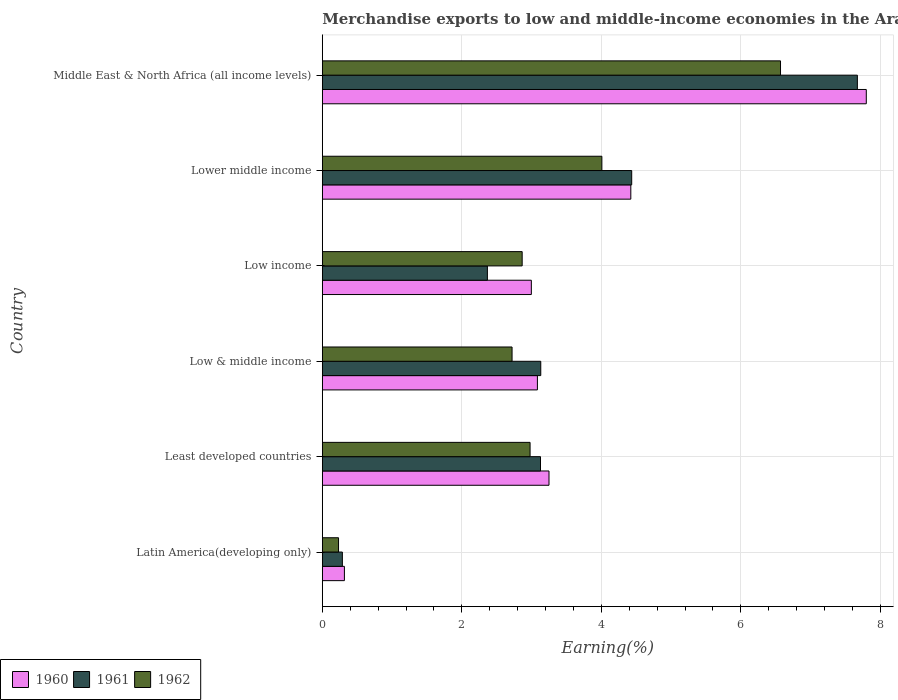How many different coloured bars are there?
Offer a very short reply. 3. How many groups of bars are there?
Offer a terse response. 6. Are the number of bars on each tick of the Y-axis equal?
Provide a short and direct response. Yes. How many bars are there on the 6th tick from the top?
Provide a short and direct response. 3. How many bars are there on the 2nd tick from the bottom?
Your answer should be compact. 3. What is the label of the 2nd group of bars from the top?
Make the answer very short. Lower middle income. In how many cases, is the number of bars for a given country not equal to the number of legend labels?
Keep it short and to the point. 0. What is the percentage of amount earned from merchandise exports in 1962 in Low & middle income?
Ensure brevity in your answer.  2.72. Across all countries, what is the maximum percentage of amount earned from merchandise exports in 1960?
Your answer should be very brief. 7.8. Across all countries, what is the minimum percentage of amount earned from merchandise exports in 1961?
Keep it short and to the point. 0.29. In which country was the percentage of amount earned from merchandise exports in 1960 maximum?
Your answer should be compact. Middle East & North Africa (all income levels). In which country was the percentage of amount earned from merchandise exports in 1960 minimum?
Give a very brief answer. Latin America(developing only). What is the total percentage of amount earned from merchandise exports in 1961 in the graph?
Give a very brief answer. 21.02. What is the difference between the percentage of amount earned from merchandise exports in 1962 in Least developed countries and that in Lower middle income?
Your answer should be compact. -1.03. What is the difference between the percentage of amount earned from merchandise exports in 1960 in Least developed countries and the percentage of amount earned from merchandise exports in 1961 in Middle East & North Africa (all income levels)?
Offer a terse response. -4.42. What is the average percentage of amount earned from merchandise exports in 1961 per country?
Your response must be concise. 3.5. What is the difference between the percentage of amount earned from merchandise exports in 1960 and percentage of amount earned from merchandise exports in 1962 in Low & middle income?
Offer a very short reply. 0.36. In how many countries, is the percentage of amount earned from merchandise exports in 1960 greater than 2.4 %?
Offer a very short reply. 5. What is the ratio of the percentage of amount earned from merchandise exports in 1960 in Latin America(developing only) to that in Lower middle income?
Give a very brief answer. 0.07. Is the percentage of amount earned from merchandise exports in 1962 in Latin America(developing only) less than that in Low & middle income?
Ensure brevity in your answer.  Yes. Is the difference between the percentage of amount earned from merchandise exports in 1960 in Latin America(developing only) and Lower middle income greater than the difference between the percentage of amount earned from merchandise exports in 1962 in Latin America(developing only) and Lower middle income?
Provide a short and direct response. No. What is the difference between the highest and the second highest percentage of amount earned from merchandise exports in 1961?
Offer a terse response. 3.23. What is the difference between the highest and the lowest percentage of amount earned from merchandise exports in 1962?
Ensure brevity in your answer.  6.34. In how many countries, is the percentage of amount earned from merchandise exports in 1961 greater than the average percentage of amount earned from merchandise exports in 1961 taken over all countries?
Provide a succinct answer. 2. Is the sum of the percentage of amount earned from merchandise exports in 1962 in Low & middle income and Low income greater than the maximum percentage of amount earned from merchandise exports in 1961 across all countries?
Give a very brief answer. No. What does the 2nd bar from the top in Least developed countries represents?
Make the answer very short. 1961. What does the 1st bar from the bottom in Latin America(developing only) represents?
Offer a terse response. 1960. How many bars are there?
Give a very brief answer. 18. How many countries are there in the graph?
Your response must be concise. 6. What is the difference between two consecutive major ticks on the X-axis?
Offer a very short reply. 2. Does the graph contain any zero values?
Offer a terse response. No. Does the graph contain grids?
Your answer should be compact. Yes. How many legend labels are there?
Keep it short and to the point. 3. What is the title of the graph?
Ensure brevity in your answer.  Merchandise exports to low and middle-income economies in the Arab World. What is the label or title of the X-axis?
Provide a short and direct response. Earning(%). What is the Earning(%) in 1960 in Latin America(developing only)?
Give a very brief answer. 0.32. What is the Earning(%) of 1961 in Latin America(developing only)?
Your answer should be compact. 0.29. What is the Earning(%) in 1962 in Latin America(developing only)?
Give a very brief answer. 0.23. What is the Earning(%) of 1960 in Least developed countries?
Provide a succinct answer. 3.25. What is the Earning(%) of 1961 in Least developed countries?
Provide a short and direct response. 3.13. What is the Earning(%) of 1962 in Least developed countries?
Make the answer very short. 2.98. What is the Earning(%) in 1960 in Low & middle income?
Provide a succinct answer. 3.08. What is the Earning(%) of 1961 in Low & middle income?
Your response must be concise. 3.13. What is the Earning(%) of 1962 in Low & middle income?
Provide a succinct answer. 2.72. What is the Earning(%) of 1960 in Low income?
Make the answer very short. 3. What is the Earning(%) of 1961 in Low income?
Offer a very short reply. 2.37. What is the Earning(%) in 1962 in Low income?
Keep it short and to the point. 2.86. What is the Earning(%) in 1960 in Lower middle income?
Offer a very short reply. 4.42. What is the Earning(%) of 1961 in Lower middle income?
Ensure brevity in your answer.  4.43. What is the Earning(%) in 1962 in Lower middle income?
Make the answer very short. 4.01. What is the Earning(%) in 1960 in Middle East & North Africa (all income levels)?
Provide a short and direct response. 7.8. What is the Earning(%) of 1961 in Middle East & North Africa (all income levels)?
Make the answer very short. 7.67. What is the Earning(%) in 1962 in Middle East & North Africa (all income levels)?
Offer a terse response. 6.57. Across all countries, what is the maximum Earning(%) of 1960?
Offer a terse response. 7.8. Across all countries, what is the maximum Earning(%) in 1961?
Your response must be concise. 7.67. Across all countries, what is the maximum Earning(%) in 1962?
Ensure brevity in your answer.  6.57. Across all countries, what is the minimum Earning(%) of 1960?
Your answer should be compact. 0.32. Across all countries, what is the minimum Earning(%) in 1961?
Your response must be concise. 0.29. Across all countries, what is the minimum Earning(%) of 1962?
Provide a succinct answer. 0.23. What is the total Earning(%) in 1960 in the graph?
Make the answer very short. 21.86. What is the total Earning(%) in 1961 in the graph?
Keep it short and to the point. 21.02. What is the total Earning(%) in 1962 in the graph?
Give a very brief answer. 19.37. What is the difference between the Earning(%) in 1960 in Latin America(developing only) and that in Least developed countries?
Offer a terse response. -2.93. What is the difference between the Earning(%) of 1961 in Latin America(developing only) and that in Least developed countries?
Keep it short and to the point. -2.84. What is the difference between the Earning(%) in 1962 in Latin America(developing only) and that in Least developed countries?
Provide a short and direct response. -2.75. What is the difference between the Earning(%) in 1960 in Latin America(developing only) and that in Low & middle income?
Ensure brevity in your answer.  -2.77. What is the difference between the Earning(%) of 1961 in Latin America(developing only) and that in Low & middle income?
Make the answer very short. -2.84. What is the difference between the Earning(%) of 1962 in Latin America(developing only) and that in Low & middle income?
Offer a very short reply. -2.49. What is the difference between the Earning(%) in 1960 in Latin America(developing only) and that in Low income?
Your answer should be very brief. -2.68. What is the difference between the Earning(%) of 1961 in Latin America(developing only) and that in Low income?
Your answer should be very brief. -2.08. What is the difference between the Earning(%) in 1962 in Latin America(developing only) and that in Low income?
Offer a terse response. -2.63. What is the difference between the Earning(%) of 1960 in Latin America(developing only) and that in Lower middle income?
Your answer should be very brief. -4.11. What is the difference between the Earning(%) in 1961 in Latin America(developing only) and that in Lower middle income?
Offer a very short reply. -4.15. What is the difference between the Earning(%) in 1962 in Latin America(developing only) and that in Lower middle income?
Offer a terse response. -3.78. What is the difference between the Earning(%) of 1960 in Latin America(developing only) and that in Middle East & North Africa (all income levels)?
Offer a terse response. -7.48. What is the difference between the Earning(%) of 1961 in Latin America(developing only) and that in Middle East & North Africa (all income levels)?
Ensure brevity in your answer.  -7.38. What is the difference between the Earning(%) of 1962 in Latin America(developing only) and that in Middle East & North Africa (all income levels)?
Provide a short and direct response. -6.34. What is the difference between the Earning(%) in 1960 in Least developed countries and that in Low & middle income?
Keep it short and to the point. 0.17. What is the difference between the Earning(%) in 1961 in Least developed countries and that in Low & middle income?
Make the answer very short. -0. What is the difference between the Earning(%) of 1962 in Least developed countries and that in Low & middle income?
Provide a short and direct response. 0.26. What is the difference between the Earning(%) of 1960 in Least developed countries and that in Low income?
Provide a short and direct response. 0.25. What is the difference between the Earning(%) in 1961 in Least developed countries and that in Low income?
Make the answer very short. 0.76. What is the difference between the Earning(%) in 1962 in Least developed countries and that in Low income?
Your answer should be compact. 0.11. What is the difference between the Earning(%) in 1960 in Least developed countries and that in Lower middle income?
Your answer should be very brief. -1.17. What is the difference between the Earning(%) of 1961 in Least developed countries and that in Lower middle income?
Ensure brevity in your answer.  -1.31. What is the difference between the Earning(%) of 1962 in Least developed countries and that in Lower middle income?
Provide a short and direct response. -1.03. What is the difference between the Earning(%) of 1960 in Least developed countries and that in Middle East & North Africa (all income levels)?
Make the answer very short. -4.55. What is the difference between the Earning(%) of 1961 in Least developed countries and that in Middle East & North Africa (all income levels)?
Ensure brevity in your answer.  -4.54. What is the difference between the Earning(%) in 1962 in Least developed countries and that in Middle East & North Africa (all income levels)?
Provide a short and direct response. -3.59. What is the difference between the Earning(%) of 1960 in Low & middle income and that in Low income?
Provide a succinct answer. 0.09. What is the difference between the Earning(%) of 1961 in Low & middle income and that in Low income?
Your answer should be very brief. 0.77. What is the difference between the Earning(%) in 1962 in Low & middle income and that in Low income?
Ensure brevity in your answer.  -0.14. What is the difference between the Earning(%) in 1960 in Low & middle income and that in Lower middle income?
Your response must be concise. -1.34. What is the difference between the Earning(%) in 1961 in Low & middle income and that in Lower middle income?
Your response must be concise. -1.3. What is the difference between the Earning(%) in 1962 in Low & middle income and that in Lower middle income?
Your response must be concise. -1.29. What is the difference between the Earning(%) of 1960 in Low & middle income and that in Middle East & North Africa (all income levels)?
Offer a very short reply. -4.71. What is the difference between the Earning(%) of 1961 in Low & middle income and that in Middle East & North Africa (all income levels)?
Keep it short and to the point. -4.54. What is the difference between the Earning(%) in 1962 in Low & middle income and that in Middle East & North Africa (all income levels)?
Give a very brief answer. -3.85. What is the difference between the Earning(%) of 1960 in Low income and that in Lower middle income?
Offer a very short reply. -1.43. What is the difference between the Earning(%) of 1961 in Low income and that in Lower middle income?
Provide a succinct answer. -2.07. What is the difference between the Earning(%) in 1962 in Low income and that in Lower middle income?
Your answer should be compact. -1.14. What is the difference between the Earning(%) in 1960 in Low income and that in Middle East & North Africa (all income levels)?
Offer a very short reply. -4.8. What is the difference between the Earning(%) of 1961 in Low income and that in Middle East & North Africa (all income levels)?
Offer a terse response. -5.3. What is the difference between the Earning(%) in 1962 in Low income and that in Middle East & North Africa (all income levels)?
Your answer should be compact. -3.7. What is the difference between the Earning(%) in 1960 in Lower middle income and that in Middle East & North Africa (all income levels)?
Make the answer very short. -3.38. What is the difference between the Earning(%) in 1961 in Lower middle income and that in Middle East & North Africa (all income levels)?
Provide a succinct answer. -3.23. What is the difference between the Earning(%) of 1962 in Lower middle income and that in Middle East & North Africa (all income levels)?
Your answer should be compact. -2.56. What is the difference between the Earning(%) in 1960 in Latin America(developing only) and the Earning(%) in 1961 in Least developed countries?
Your answer should be compact. -2.81. What is the difference between the Earning(%) of 1960 in Latin America(developing only) and the Earning(%) of 1962 in Least developed countries?
Offer a terse response. -2.66. What is the difference between the Earning(%) in 1961 in Latin America(developing only) and the Earning(%) in 1962 in Least developed countries?
Give a very brief answer. -2.69. What is the difference between the Earning(%) of 1960 in Latin America(developing only) and the Earning(%) of 1961 in Low & middle income?
Your answer should be compact. -2.81. What is the difference between the Earning(%) of 1960 in Latin America(developing only) and the Earning(%) of 1962 in Low & middle income?
Make the answer very short. -2.4. What is the difference between the Earning(%) of 1961 in Latin America(developing only) and the Earning(%) of 1962 in Low & middle income?
Ensure brevity in your answer.  -2.43. What is the difference between the Earning(%) of 1960 in Latin America(developing only) and the Earning(%) of 1961 in Low income?
Provide a short and direct response. -2.05. What is the difference between the Earning(%) of 1960 in Latin America(developing only) and the Earning(%) of 1962 in Low income?
Offer a very short reply. -2.55. What is the difference between the Earning(%) in 1961 in Latin America(developing only) and the Earning(%) in 1962 in Low income?
Keep it short and to the point. -2.58. What is the difference between the Earning(%) of 1960 in Latin America(developing only) and the Earning(%) of 1961 in Lower middle income?
Provide a succinct answer. -4.12. What is the difference between the Earning(%) in 1960 in Latin America(developing only) and the Earning(%) in 1962 in Lower middle income?
Your answer should be compact. -3.69. What is the difference between the Earning(%) of 1961 in Latin America(developing only) and the Earning(%) of 1962 in Lower middle income?
Give a very brief answer. -3.72. What is the difference between the Earning(%) of 1960 in Latin America(developing only) and the Earning(%) of 1961 in Middle East & North Africa (all income levels)?
Your answer should be compact. -7.35. What is the difference between the Earning(%) in 1960 in Latin America(developing only) and the Earning(%) in 1962 in Middle East & North Africa (all income levels)?
Provide a short and direct response. -6.25. What is the difference between the Earning(%) in 1961 in Latin America(developing only) and the Earning(%) in 1962 in Middle East & North Africa (all income levels)?
Give a very brief answer. -6.28. What is the difference between the Earning(%) of 1960 in Least developed countries and the Earning(%) of 1961 in Low & middle income?
Ensure brevity in your answer.  0.12. What is the difference between the Earning(%) of 1960 in Least developed countries and the Earning(%) of 1962 in Low & middle income?
Ensure brevity in your answer.  0.53. What is the difference between the Earning(%) in 1961 in Least developed countries and the Earning(%) in 1962 in Low & middle income?
Your response must be concise. 0.41. What is the difference between the Earning(%) in 1960 in Least developed countries and the Earning(%) in 1961 in Low income?
Your response must be concise. 0.88. What is the difference between the Earning(%) of 1960 in Least developed countries and the Earning(%) of 1962 in Low income?
Keep it short and to the point. 0.38. What is the difference between the Earning(%) of 1961 in Least developed countries and the Earning(%) of 1962 in Low income?
Your response must be concise. 0.26. What is the difference between the Earning(%) in 1960 in Least developed countries and the Earning(%) in 1961 in Lower middle income?
Your answer should be compact. -1.19. What is the difference between the Earning(%) of 1960 in Least developed countries and the Earning(%) of 1962 in Lower middle income?
Ensure brevity in your answer.  -0.76. What is the difference between the Earning(%) of 1961 in Least developed countries and the Earning(%) of 1962 in Lower middle income?
Your answer should be compact. -0.88. What is the difference between the Earning(%) in 1960 in Least developed countries and the Earning(%) in 1961 in Middle East & North Africa (all income levels)?
Provide a short and direct response. -4.42. What is the difference between the Earning(%) of 1960 in Least developed countries and the Earning(%) of 1962 in Middle East & North Africa (all income levels)?
Ensure brevity in your answer.  -3.32. What is the difference between the Earning(%) in 1961 in Least developed countries and the Earning(%) in 1962 in Middle East & North Africa (all income levels)?
Offer a terse response. -3.44. What is the difference between the Earning(%) of 1960 in Low & middle income and the Earning(%) of 1961 in Low income?
Provide a succinct answer. 0.72. What is the difference between the Earning(%) of 1960 in Low & middle income and the Earning(%) of 1962 in Low income?
Your response must be concise. 0.22. What is the difference between the Earning(%) in 1961 in Low & middle income and the Earning(%) in 1962 in Low income?
Offer a terse response. 0.27. What is the difference between the Earning(%) of 1960 in Low & middle income and the Earning(%) of 1961 in Lower middle income?
Provide a short and direct response. -1.35. What is the difference between the Earning(%) of 1960 in Low & middle income and the Earning(%) of 1962 in Lower middle income?
Provide a short and direct response. -0.92. What is the difference between the Earning(%) of 1961 in Low & middle income and the Earning(%) of 1962 in Lower middle income?
Keep it short and to the point. -0.88. What is the difference between the Earning(%) in 1960 in Low & middle income and the Earning(%) in 1961 in Middle East & North Africa (all income levels)?
Offer a terse response. -4.59. What is the difference between the Earning(%) in 1960 in Low & middle income and the Earning(%) in 1962 in Middle East & North Africa (all income levels)?
Give a very brief answer. -3.48. What is the difference between the Earning(%) of 1961 in Low & middle income and the Earning(%) of 1962 in Middle East & North Africa (all income levels)?
Ensure brevity in your answer.  -3.44. What is the difference between the Earning(%) of 1960 in Low income and the Earning(%) of 1961 in Lower middle income?
Give a very brief answer. -1.44. What is the difference between the Earning(%) in 1960 in Low income and the Earning(%) in 1962 in Lower middle income?
Your answer should be very brief. -1.01. What is the difference between the Earning(%) in 1961 in Low income and the Earning(%) in 1962 in Lower middle income?
Your response must be concise. -1.64. What is the difference between the Earning(%) of 1960 in Low income and the Earning(%) of 1961 in Middle East & North Africa (all income levels)?
Keep it short and to the point. -4.67. What is the difference between the Earning(%) of 1960 in Low income and the Earning(%) of 1962 in Middle East & North Africa (all income levels)?
Keep it short and to the point. -3.57. What is the difference between the Earning(%) of 1961 in Low income and the Earning(%) of 1962 in Middle East & North Africa (all income levels)?
Give a very brief answer. -4.2. What is the difference between the Earning(%) of 1960 in Lower middle income and the Earning(%) of 1961 in Middle East & North Africa (all income levels)?
Your answer should be compact. -3.25. What is the difference between the Earning(%) in 1960 in Lower middle income and the Earning(%) in 1962 in Middle East & North Africa (all income levels)?
Give a very brief answer. -2.15. What is the difference between the Earning(%) in 1961 in Lower middle income and the Earning(%) in 1962 in Middle East & North Africa (all income levels)?
Your answer should be very brief. -2.13. What is the average Earning(%) in 1960 per country?
Provide a short and direct response. 3.64. What is the average Earning(%) in 1961 per country?
Your response must be concise. 3.5. What is the average Earning(%) of 1962 per country?
Your response must be concise. 3.23. What is the difference between the Earning(%) of 1960 and Earning(%) of 1961 in Latin America(developing only)?
Your response must be concise. 0.03. What is the difference between the Earning(%) in 1960 and Earning(%) in 1962 in Latin America(developing only)?
Provide a short and direct response. 0.08. What is the difference between the Earning(%) in 1961 and Earning(%) in 1962 in Latin America(developing only)?
Provide a short and direct response. 0.06. What is the difference between the Earning(%) in 1960 and Earning(%) in 1961 in Least developed countries?
Your answer should be compact. 0.12. What is the difference between the Earning(%) of 1960 and Earning(%) of 1962 in Least developed countries?
Make the answer very short. 0.27. What is the difference between the Earning(%) of 1961 and Earning(%) of 1962 in Least developed countries?
Ensure brevity in your answer.  0.15. What is the difference between the Earning(%) in 1960 and Earning(%) in 1961 in Low & middle income?
Your response must be concise. -0.05. What is the difference between the Earning(%) in 1960 and Earning(%) in 1962 in Low & middle income?
Give a very brief answer. 0.36. What is the difference between the Earning(%) in 1961 and Earning(%) in 1962 in Low & middle income?
Your answer should be compact. 0.41. What is the difference between the Earning(%) in 1960 and Earning(%) in 1961 in Low income?
Make the answer very short. 0.63. What is the difference between the Earning(%) in 1960 and Earning(%) in 1962 in Low income?
Make the answer very short. 0.13. What is the difference between the Earning(%) of 1961 and Earning(%) of 1962 in Low income?
Provide a short and direct response. -0.5. What is the difference between the Earning(%) of 1960 and Earning(%) of 1961 in Lower middle income?
Provide a short and direct response. -0.01. What is the difference between the Earning(%) in 1960 and Earning(%) in 1962 in Lower middle income?
Offer a terse response. 0.41. What is the difference between the Earning(%) of 1961 and Earning(%) of 1962 in Lower middle income?
Your answer should be very brief. 0.43. What is the difference between the Earning(%) in 1960 and Earning(%) in 1961 in Middle East & North Africa (all income levels)?
Offer a very short reply. 0.13. What is the difference between the Earning(%) of 1960 and Earning(%) of 1962 in Middle East & North Africa (all income levels)?
Keep it short and to the point. 1.23. What is the difference between the Earning(%) in 1961 and Earning(%) in 1962 in Middle East & North Africa (all income levels)?
Provide a succinct answer. 1.1. What is the ratio of the Earning(%) in 1960 in Latin America(developing only) to that in Least developed countries?
Make the answer very short. 0.1. What is the ratio of the Earning(%) of 1961 in Latin America(developing only) to that in Least developed countries?
Provide a short and direct response. 0.09. What is the ratio of the Earning(%) of 1962 in Latin America(developing only) to that in Least developed countries?
Make the answer very short. 0.08. What is the ratio of the Earning(%) in 1960 in Latin America(developing only) to that in Low & middle income?
Keep it short and to the point. 0.1. What is the ratio of the Earning(%) of 1961 in Latin America(developing only) to that in Low & middle income?
Provide a short and direct response. 0.09. What is the ratio of the Earning(%) in 1962 in Latin America(developing only) to that in Low & middle income?
Offer a very short reply. 0.09. What is the ratio of the Earning(%) of 1960 in Latin America(developing only) to that in Low income?
Provide a succinct answer. 0.11. What is the ratio of the Earning(%) in 1961 in Latin America(developing only) to that in Low income?
Your answer should be compact. 0.12. What is the ratio of the Earning(%) in 1962 in Latin America(developing only) to that in Low income?
Provide a short and direct response. 0.08. What is the ratio of the Earning(%) of 1960 in Latin America(developing only) to that in Lower middle income?
Your answer should be compact. 0.07. What is the ratio of the Earning(%) of 1961 in Latin America(developing only) to that in Lower middle income?
Provide a short and direct response. 0.06. What is the ratio of the Earning(%) in 1962 in Latin America(developing only) to that in Lower middle income?
Give a very brief answer. 0.06. What is the ratio of the Earning(%) in 1960 in Latin America(developing only) to that in Middle East & North Africa (all income levels)?
Give a very brief answer. 0.04. What is the ratio of the Earning(%) of 1961 in Latin America(developing only) to that in Middle East & North Africa (all income levels)?
Offer a terse response. 0.04. What is the ratio of the Earning(%) in 1962 in Latin America(developing only) to that in Middle East & North Africa (all income levels)?
Ensure brevity in your answer.  0.04. What is the ratio of the Earning(%) in 1960 in Least developed countries to that in Low & middle income?
Keep it short and to the point. 1.05. What is the ratio of the Earning(%) in 1962 in Least developed countries to that in Low & middle income?
Give a very brief answer. 1.09. What is the ratio of the Earning(%) of 1960 in Least developed countries to that in Low income?
Your answer should be compact. 1.08. What is the ratio of the Earning(%) of 1961 in Least developed countries to that in Low income?
Make the answer very short. 1.32. What is the ratio of the Earning(%) of 1962 in Least developed countries to that in Low income?
Give a very brief answer. 1.04. What is the ratio of the Earning(%) of 1960 in Least developed countries to that in Lower middle income?
Offer a very short reply. 0.73. What is the ratio of the Earning(%) in 1961 in Least developed countries to that in Lower middle income?
Your response must be concise. 0.71. What is the ratio of the Earning(%) of 1962 in Least developed countries to that in Lower middle income?
Your answer should be very brief. 0.74. What is the ratio of the Earning(%) in 1960 in Least developed countries to that in Middle East & North Africa (all income levels)?
Your answer should be very brief. 0.42. What is the ratio of the Earning(%) of 1961 in Least developed countries to that in Middle East & North Africa (all income levels)?
Provide a short and direct response. 0.41. What is the ratio of the Earning(%) in 1962 in Least developed countries to that in Middle East & North Africa (all income levels)?
Keep it short and to the point. 0.45. What is the ratio of the Earning(%) of 1961 in Low & middle income to that in Low income?
Keep it short and to the point. 1.32. What is the ratio of the Earning(%) in 1962 in Low & middle income to that in Low income?
Your response must be concise. 0.95. What is the ratio of the Earning(%) in 1960 in Low & middle income to that in Lower middle income?
Make the answer very short. 0.7. What is the ratio of the Earning(%) in 1961 in Low & middle income to that in Lower middle income?
Your answer should be very brief. 0.71. What is the ratio of the Earning(%) in 1962 in Low & middle income to that in Lower middle income?
Your response must be concise. 0.68. What is the ratio of the Earning(%) in 1960 in Low & middle income to that in Middle East & North Africa (all income levels)?
Make the answer very short. 0.4. What is the ratio of the Earning(%) in 1961 in Low & middle income to that in Middle East & North Africa (all income levels)?
Your answer should be very brief. 0.41. What is the ratio of the Earning(%) of 1962 in Low & middle income to that in Middle East & North Africa (all income levels)?
Keep it short and to the point. 0.41. What is the ratio of the Earning(%) of 1960 in Low income to that in Lower middle income?
Your response must be concise. 0.68. What is the ratio of the Earning(%) of 1961 in Low income to that in Lower middle income?
Provide a succinct answer. 0.53. What is the ratio of the Earning(%) of 1962 in Low income to that in Lower middle income?
Offer a very short reply. 0.71. What is the ratio of the Earning(%) of 1960 in Low income to that in Middle East & North Africa (all income levels)?
Offer a terse response. 0.38. What is the ratio of the Earning(%) in 1961 in Low income to that in Middle East & North Africa (all income levels)?
Make the answer very short. 0.31. What is the ratio of the Earning(%) of 1962 in Low income to that in Middle East & North Africa (all income levels)?
Your answer should be compact. 0.44. What is the ratio of the Earning(%) of 1960 in Lower middle income to that in Middle East & North Africa (all income levels)?
Keep it short and to the point. 0.57. What is the ratio of the Earning(%) of 1961 in Lower middle income to that in Middle East & North Africa (all income levels)?
Make the answer very short. 0.58. What is the ratio of the Earning(%) in 1962 in Lower middle income to that in Middle East & North Africa (all income levels)?
Offer a terse response. 0.61. What is the difference between the highest and the second highest Earning(%) in 1960?
Make the answer very short. 3.38. What is the difference between the highest and the second highest Earning(%) in 1961?
Your response must be concise. 3.23. What is the difference between the highest and the second highest Earning(%) of 1962?
Ensure brevity in your answer.  2.56. What is the difference between the highest and the lowest Earning(%) in 1960?
Keep it short and to the point. 7.48. What is the difference between the highest and the lowest Earning(%) in 1961?
Offer a very short reply. 7.38. What is the difference between the highest and the lowest Earning(%) in 1962?
Your answer should be very brief. 6.34. 